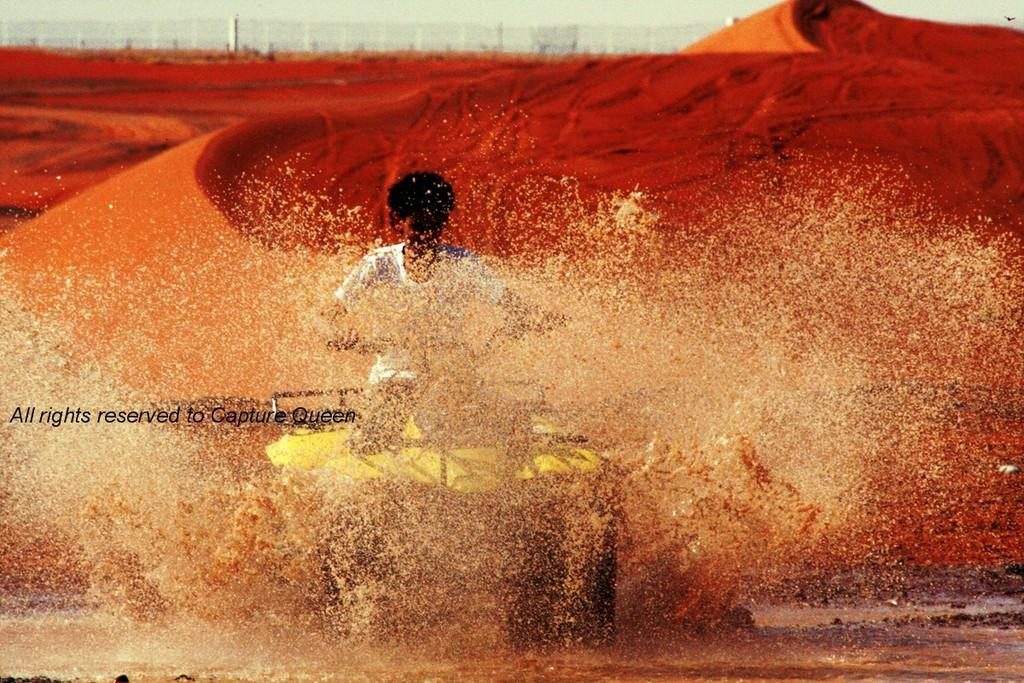Who or what is present in the image? There is a person in the image. What natural element can be seen in the image? There is water visible in the image. What type of terrain is present in the image? There is sand in the image. What architectural feature can be seen in the image? There is a fence in the image. What is visible in the background of the image? The sky is visible in the background of the image. What type of clam is being rubbed in the game depicted in the image? There is no clam or game present in the image; it features a person, water, sand, a fence, and the sky. 